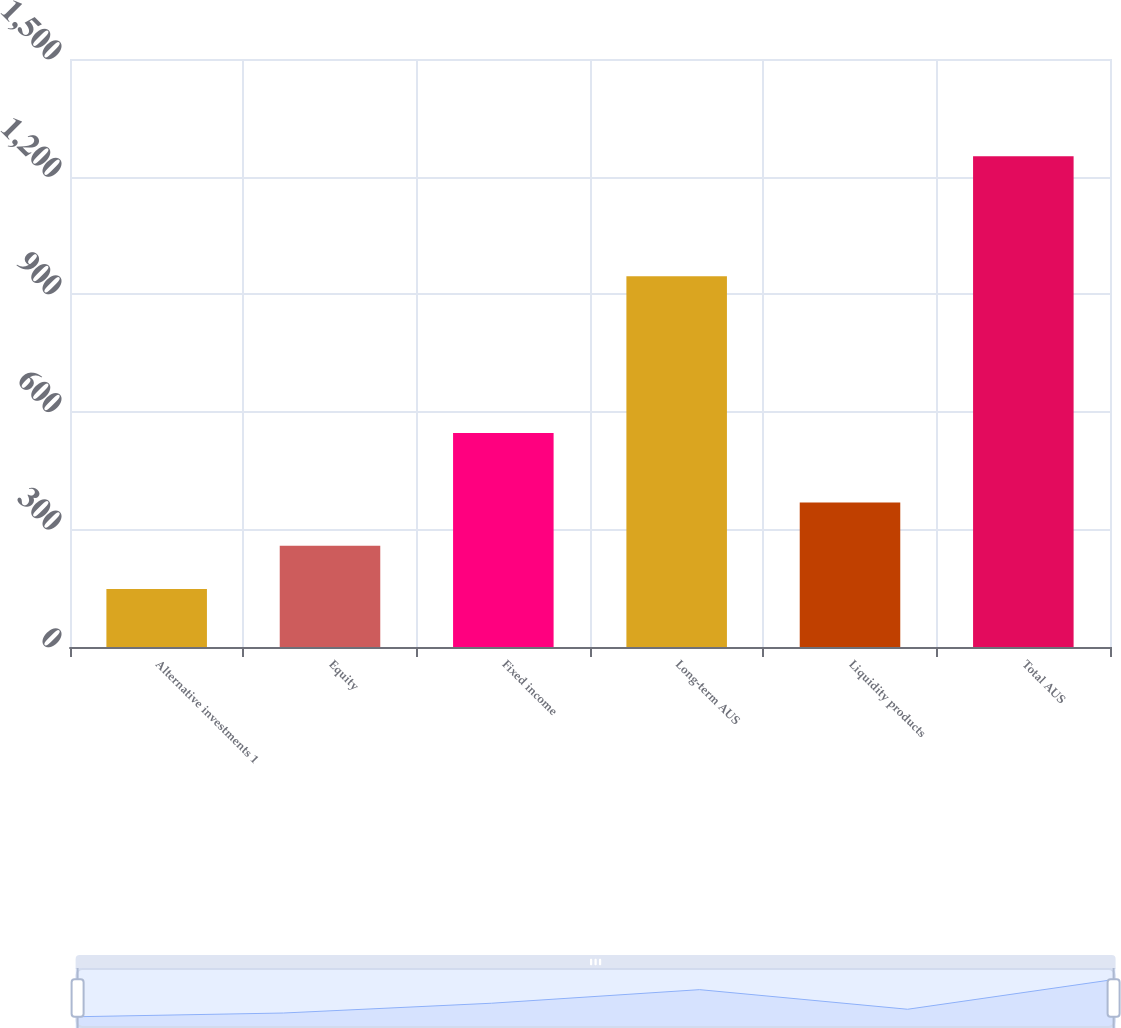Convert chart. <chart><loc_0><loc_0><loc_500><loc_500><bar_chart><fcel>Alternative investments 1<fcel>Equity<fcel>Fixed income<fcel>Long-term AUS<fcel>Liquidity products<fcel>Total AUS<nl><fcel>148<fcel>258.4<fcel>546<fcel>946<fcel>368.8<fcel>1252<nl></chart> 